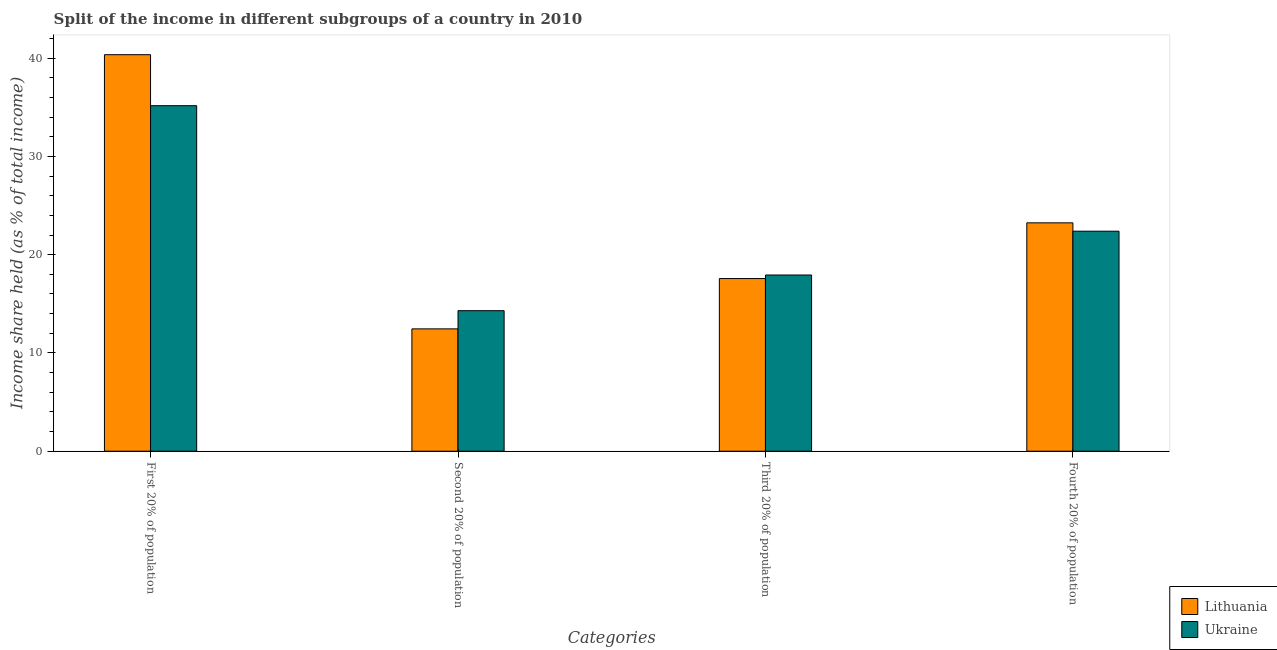How many different coloured bars are there?
Your response must be concise. 2. Are the number of bars per tick equal to the number of legend labels?
Your answer should be compact. Yes. Are the number of bars on each tick of the X-axis equal?
Provide a short and direct response. Yes. How many bars are there on the 1st tick from the right?
Offer a very short reply. 2. What is the label of the 3rd group of bars from the left?
Your answer should be very brief. Third 20% of population. What is the share of the income held by fourth 20% of the population in Lithuania?
Your response must be concise. 23.24. Across all countries, what is the maximum share of the income held by second 20% of the population?
Provide a short and direct response. 14.3. Across all countries, what is the minimum share of the income held by third 20% of the population?
Your response must be concise. 17.57. In which country was the share of the income held by first 20% of the population maximum?
Your response must be concise. Lithuania. In which country was the share of the income held by first 20% of the population minimum?
Ensure brevity in your answer.  Ukraine. What is the total share of the income held by first 20% of the population in the graph?
Your answer should be compact. 75.51. What is the difference between the share of the income held by first 20% of the population in Ukraine and that in Lithuania?
Offer a very short reply. -5.19. What is the difference between the share of the income held by fourth 20% of the population in Lithuania and the share of the income held by third 20% of the population in Ukraine?
Offer a very short reply. 5.31. What is the average share of the income held by second 20% of the population per country?
Keep it short and to the point. 13.38. What is the difference between the share of the income held by first 20% of the population and share of the income held by third 20% of the population in Lithuania?
Ensure brevity in your answer.  22.78. What is the ratio of the share of the income held by fourth 20% of the population in Ukraine to that in Lithuania?
Your answer should be compact. 0.96. Is the share of the income held by third 20% of the population in Ukraine less than that in Lithuania?
Keep it short and to the point. No. Is the difference between the share of the income held by fourth 20% of the population in Lithuania and Ukraine greater than the difference between the share of the income held by second 20% of the population in Lithuania and Ukraine?
Make the answer very short. Yes. What is the difference between the highest and the second highest share of the income held by first 20% of the population?
Offer a very short reply. 5.19. What is the difference between the highest and the lowest share of the income held by first 20% of the population?
Your answer should be very brief. 5.19. Is the sum of the share of the income held by second 20% of the population in Ukraine and Lithuania greater than the maximum share of the income held by first 20% of the population across all countries?
Your answer should be very brief. No. What does the 2nd bar from the left in Third 20% of population represents?
Keep it short and to the point. Ukraine. What does the 1st bar from the right in Third 20% of population represents?
Provide a short and direct response. Ukraine. How many bars are there?
Your response must be concise. 8. Are all the bars in the graph horizontal?
Your answer should be very brief. No. Are the values on the major ticks of Y-axis written in scientific E-notation?
Make the answer very short. No. Does the graph contain any zero values?
Offer a terse response. No. Does the graph contain grids?
Offer a terse response. No. Where does the legend appear in the graph?
Your response must be concise. Bottom right. How many legend labels are there?
Your answer should be very brief. 2. What is the title of the graph?
Offer a very short reply. Split of the income in different subgroups of a country in 2010. Does "Eritrea" appear as one of the legend labels in the graph?
Keep it short and to the point. No. What is the label or title of the X-axis?
Offer a terse response. Categories. What is the label or title of the Y-axis?
Your answer should be compact. Income share held (as % of total income). What is the Income share held (as % of total income) in Lithuania in First 20% of population?
Your answer should be very brief. 40.35. What is the Income share held (as % of total income) of Ukraine in First 20% of population?
Give a very brief answer. 35.16. What is the Income share held (as % of total income) in Lithuania in Second 20% of population?
Offer a terse response. 12.45. What is the Income share held (as % of total income) in Lithuania in Third 20% of population?
Make the answer very short. 17.57. What is the Income share held (as % of total income) of Ukraine in Third 20% of population?
Give a very brief answer. 17.93. What is the Income share held (as % of total income) in Lithuania in Fourth 20% of population?
Give a very brief answer. 23.24. What is the Income share held (as % of total income) of Ukraine in Fourth 20% of population?
Make the answer very short. 22.39. Across all Categories, what is the maximum Income share held (as % of total income) of Lithuania?
Your answer should be compact. 40.35. Across all Categories, what is the maximum Income share held (as % of total income) in Ukraine?
Give a very brief answer. 35.16. Across all Categories, what is the minimum Income share held (as % of total income) in Lithuania?
Offer a terse response. 12.45. Across all Categories, what is the minimum Income share held (as % of total income) in Ukraine?
Provide a succinct answer. 14.3. What is the total Income share held (as % of total income) of Lithuania in the graph?
Your answer should be compact. 93.61. What is the total Income share held (as % of total income) in Ukraine in the graph?
Keep it short and to the point. 89.78. What is the difference between the Income share held (as % of total income) in Lithuania in First 20% of population and that in Second 20% of population?
Give a very brief answer. 27.9. What is the difference between the Income share held (as % of total income) in Ukraine in First 20% of population and that in Second 20% of population?
Keep it short and to the point. 20.86. What is the difference between the Income share held (as % of total income) of Lithuania in First 20% of population and that in Third 20% of population?
Give a very brief answer. 22.78. What is the difference between the Income share held (as % of total income) of Ukraine in First 20% of population and that in Third 20% of population?
Your answer should be very brief. 17.23. What is the difference between the Income share held (as % of total income) of Lithuania in First 20% of population and that in Fourth 20% of population?
Your answer should be compact. 17.11. What is the difference between the Income share held (as % of total income) of Ukraine in First 20% of population and that in Fourth 20% of population?
Offer a terse response. 12.77. What is the difference between the Income share held (as % of total income) of Lithuania in Second 20% of population and that in Third 20% of population?
Offer a terse response. -5.12. What is the difference between the Income share held (as % of total income) of Ukraine in Second 20% of population and that in Third 20% of population?
Provide a succinct answer. -3.63. What is the difference between the Income share held (as % of total income) in Lithuania in Second 20% of population and that in Fourth 20% of population?
Your answer should be compact. -10.79. What is the difference between the Income share held (as % of total income) in Ukraine in Second 20% of population and that in Fourth 20% of population?
Make the answer very short. -8.09. What is the difference between the Income share held (as % of total income) of Lithuania in Third 20% of population and that in Fourth 20% of population?
Provide a succinct answer. -5.67. What is the difference between the Income share held (as % of total income) in Ukraine in Third 20% of population and that in Fourth 20% of population?
Provide a short and direct response. -4.46. What is the difference between the Income share held (as % of total income) of Lithuania in First 20% of population and the Income share held (as % of total income) of Ukraine in Second 20% of population?
Make the answer very short. 26.05. What is the difference between the Income share held (as % of total income) of Lithuania in First 20% of population and the Income share held (as % of total income) of Ukraine in Third 20% of population?
Ensure brevity in your answer.  22.42. What is the difference between the Income share held (as % of total income) of Lithuania in First 20% of population and the Income share held (as % of total income) of Ukraine in Fourth 20% of population?
Offer a very short reply. 17.96. What is the difference between the Income share held (as % of total income) in Lithuania in Second 20% of population and the Income share held (as % of total income) in Ukraine in Third 20% of population?
Your answer should be very brief. -5.48. What is the difference between the Income share held (as % of total income) of Lithuania in Second 20% of population and the Income share held (as % of total income) of Ukraine in Fourth 20% of population?
Keep it short and to the point. -9.94. What is the difference between the Income share held (as % of total income) in Lithuania in Third 20% of population and the Income share held (as % of total income) in Ukraine in Fourth 20% of population?
Offer a terse response. -4.82. What is the average Income share held (as % of total income) of Lithuania per Categories?
Your answer should be compact. 23.4. What is the average Income share held (as % of total income) of Ukraine per Categories?
Offer a terse response. 22.45. What is the difference between the Income share held (as % of total income) of Lithuania and Income share held (as % of total income) of Ukraine in First 20% of population?
Your answer should be compact. 5.19. What is the difference between the Income share held (as % of total income) in Lithuania and Income share held (as % of total income) in Ukraine in Second 20% of population?
Ensure brevity in your answer.  -1.85. What is the difference between the Income share held (as % of total income) in Lithuania and Income share held (as % of total income) in Ukraine in Third 20% of population?
Keep it short and to the point. -0.36. What is the ratio of the Income share held (as % of total income) in Lithuania in First 20% of population to that in Second 20% of population?
Your answer should be very brief. 3.24. What is the ratio of the Income share held (as % of total income) of Ukraine in First 20% of population to that in Second 20% of population?
Offer a terse response. 2.46. What is the ratio of the Income share held (as % of total income) in Lithuania in First 20% of population to that in Third 20% of population?
Your answer should be very brief. 2.3. What is the ratio of the Income share held (as % of total income) in Ukraine in First 20% of population to that in Third 20% of population?
Ensure brevity in your answer.  1.96. What is the ratio of the Income share held (as % of total income) in Lithuania in First 20% of population to that in Fourth 20% of population?
Your answer should be compact. 1.74. What is the ratio of the Income share held (as % of total income) in Ukraine in First 20% of population to that in Fourth 20% of population?
Provide a succinct answer. 1.57. What is the ratio of the Income share held (as % of total income) in Lithuania in Second 20% of population to that in Third 20% of population?
Provide a succinct answer. 0.71. What is the ratio of the Income share held (as % of total income) of Ukraine in Second 20% of population to that in Third 20% of population?
Make the answer very short. 0.8. What is the ratio of the Income share held (as % of total income) of Lithuania in Second 20% of population to that in Fourth 20% of population?
Your response must be concise. 0.54. What is the ratio of the Income share held (as % of total income) of Ukraine in Second 20% of population to that in Fourth 20% of population?
Your answer should be very brief. 0.64. What is the ratio of the Income share held (as % of total income) of Lithuania in Third 20% of population to that in Fourth 20% of population?
Offer a very short reply. 0.76. What is the ratio of the Income share held (as % of total income) of Ukraine in Third 20% of population to that in Fourth 20% of population?
Your answer should be very brief. 0.8. What is the difference between the highest and the second highest Income share held (as % of total income) in Lithuania?
Your answer should be very brief. 17.11. What is the difference between the highest and the second highest Income share held (as % of total income) of Ukraine?
Your answer should be very brief. 12.77. What is the difference between the highest and the lowest Income share held (as % of total income) in Lithuania?
Provide a short and direct response. 27.9. What is the difference between the highest and the lowest Income share held (as % of total income) in Ukraine?
Offer a very short reply. 20.86. 